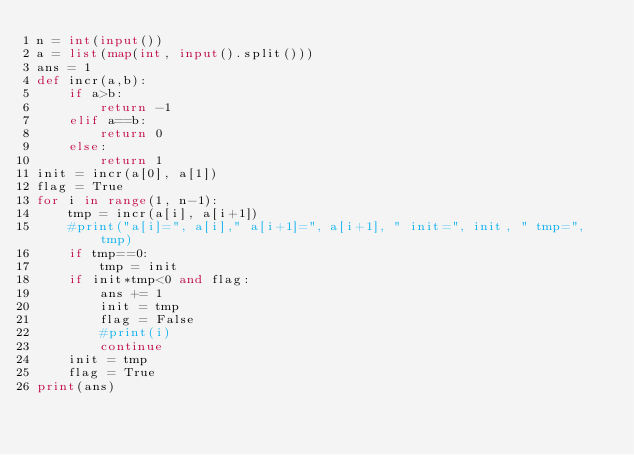Convert code to text. <code><loc_0><loc_0><loc_500><loc_500><_Python_>n = int(input())
a = list(map(int, input().split()))
ans = 1
def incr(a,b):
    if a>b:
        return -1
    elif a==b:
        return 0
    else:
        return 1
init = incr(a[0], a[1])
flag = True
for i in range(1, n-1):
    tmp = incr(a[i], a[i+1])
    #print("a[i]=", a[i]," a[i+1]=", a[i+1], " init=", init, " tmp=", tmp)
    if tmp==0:
        tmp = init
    if init*tmp<0 and flag:
        ans += 1
        init = tmp
        flag = False
        #print(i)
        continue
    init = tmp
    flag = True
print(ans)
</code> 